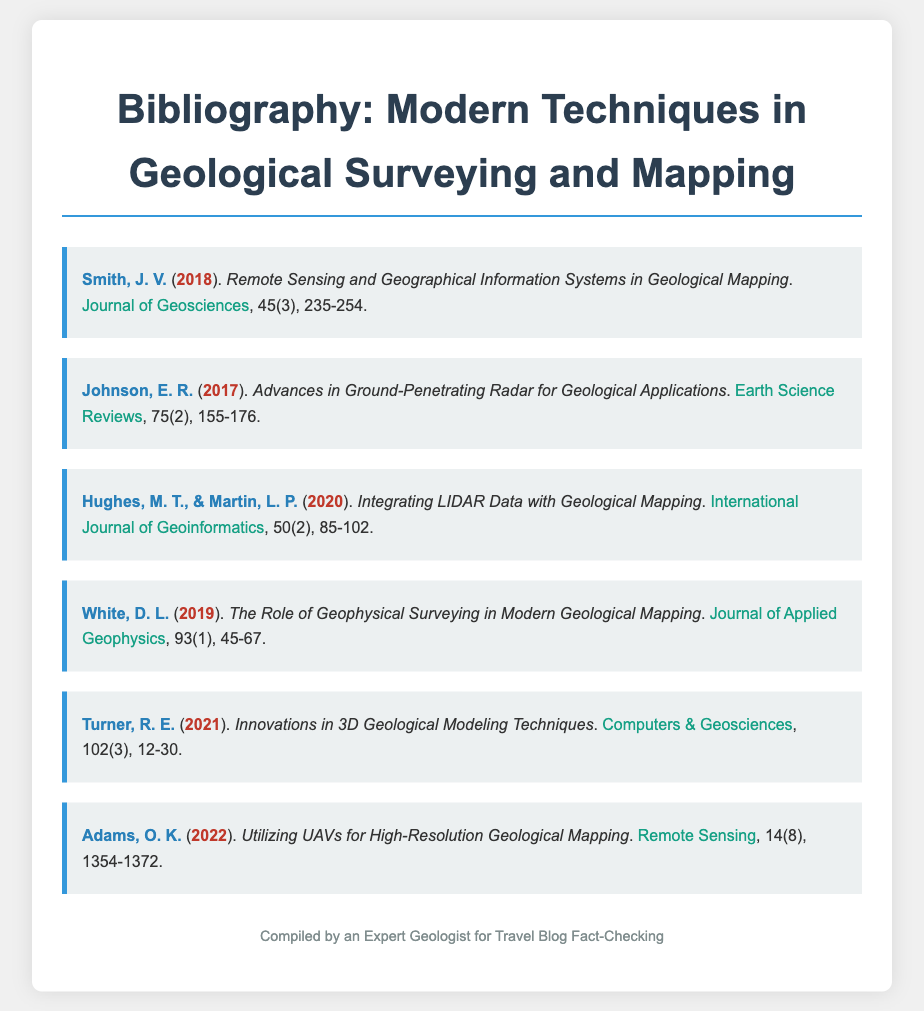What is the title of the document? The title of the document is provided at the top of the rendered HTML as "Bibliography: Modern Techniques in Geological Surveying and Mapping".
Answer: Bibliography: Modern Techniques in Geological Surveying and Mapping Who is the author of the paper published in 2020? The document lists multiple authors and their papers along with publication years; for 2020, the authors are Hughes, M. T., & Martin, L. P.
Answer: Hughes, M. T., & Martin, L. P What is the journal name for the article by Johnson, E. R.? Each bibliographic entry includes the title of the article and the journal in which it was published. For Johnson, E. R., the journal is "Earth Science Reviews".
Answer: Earth Science Reviews In what year was the article about integrating LIDAR data published? The year of publication for each article is clearly noted in parentheses after the author’s name; for integrating LIDAR data, it was published in 2020.
Answer: 2020 How many articles in the bibliography are published after 2018? By counting the years after 2018 listed in the document entries, there are three articles published after that year: 2019, 2021, and 2022.
Answer: 3 What is the topic of the article authored by Adams, O. K.? Each entry has a title that indicates the topic; Adams, O. K.'s article discusses the use of UAVs in geological mapping.
Answer: Utilizing UAVs for High-Resolution Geological Mapping Which year did Turner, R. E. publish his work? The publication year for the article by Turner, R. E. is located next to his name in the bibliography entry, which is 2021.
Answer: 2021 What is a common theme present in the bibliography? Reviewing the titles indicates a focus on modern technologies and techniques used in geological surveying and mapping, such as LIDAR and UAVs.
Answer: Modern technologies in geological surveying and mapping 